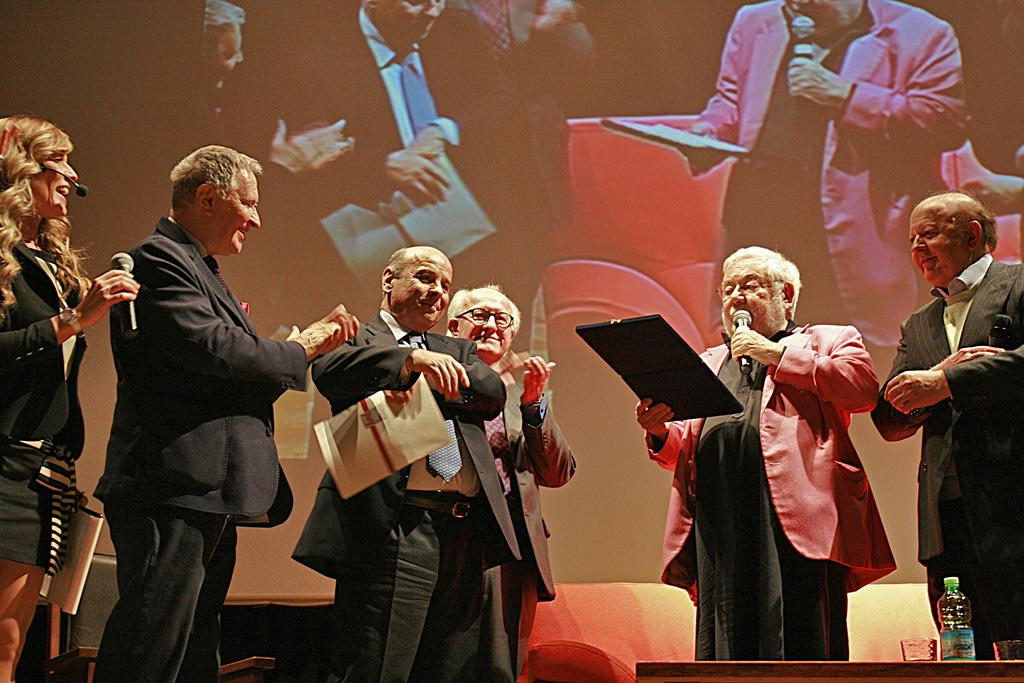What is happening in the image? There is a group of persons on stage. What are some of the persons holding? Some of the persons are holding microphones and some are holding papers. What can be seen in the background of the image? There is a screen in the background of the image. Where is the cactus located in the image? There is no cactus present in the image. Can you tell me if the porter is helping someone in the image? There is no mention of a porter or anyone needing help in the image. 